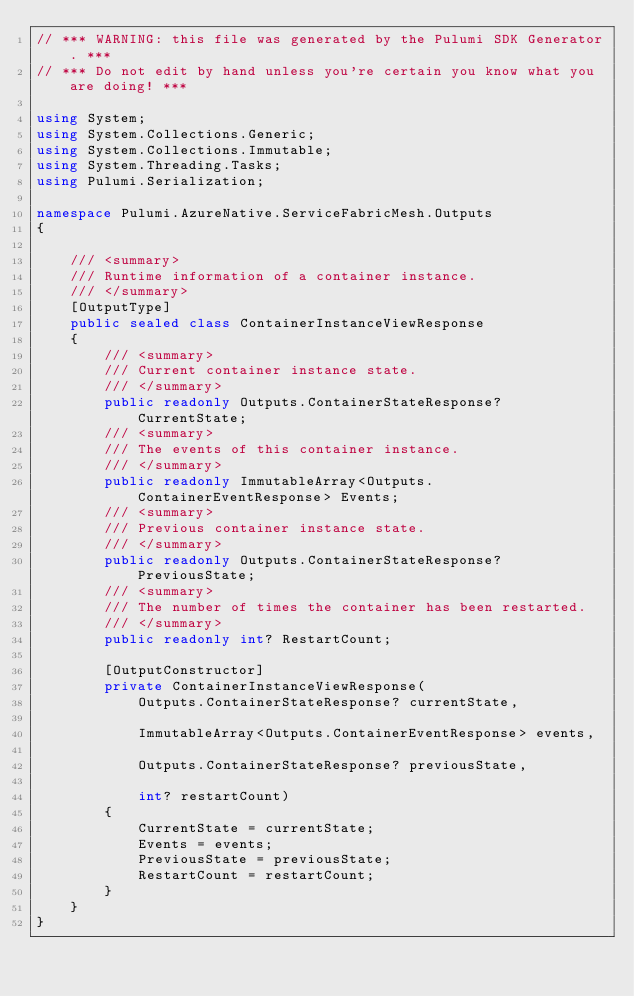<code> <loc_0><loc_0><loc_500><loc_500><_C#_>// *** WARNING: this file was generated by the Pulumi SDK Generator. ***
// *** Do not edit by hand unless you're certain you know what you are doing! ***

using System;
using System.Collections.Generic;
using System.Collections.Immutable;
using System.Threading.Tasks;
using Pulumi.Serialization;

namespace Pulumi.AzureNative.ServiceFabricMesh.Outputs
{

    /// <summary>
    /// Runtime information of a container instance.
    /// </summary>
    [OutputType]
    public sealed class ContainerInstanceViewResponse
    {
        /// <summary>
        /// Current container instance state.
        /// </summary>
        public readonly Outputs.ContainerStateResponse? CurrentState;
        /// <summary>
        /// The events of this container instance.
        /// </summary>
        public readonly ImmutableArray<Outputs.ContainerEventResponse> Events;
        /// <summary>
        /// Previous container instance state.
        /// </summary>
        public readonly Outputs.ContainerStateResponse? PreviousState;
        /// <summary>
        /// The number of times the container has been restarted.
        /// </summary>
        public readonly int? RestartCount;

        [OutputConstructor]
        private ContainerInstanceViewResponse(
            Outputs.ContainerStateResponse? currentState,

            ImmutableArray<Outputs.ContainerEventResponse> events,

            Outputs.ContainerStateResponse? previousState,

            int? restartCount)
        {
            CurrentState = currentState;
            Events = events;
            PreviousState = previousState;
            RestartCount = restartCount;
        }
    }
}
</code> 